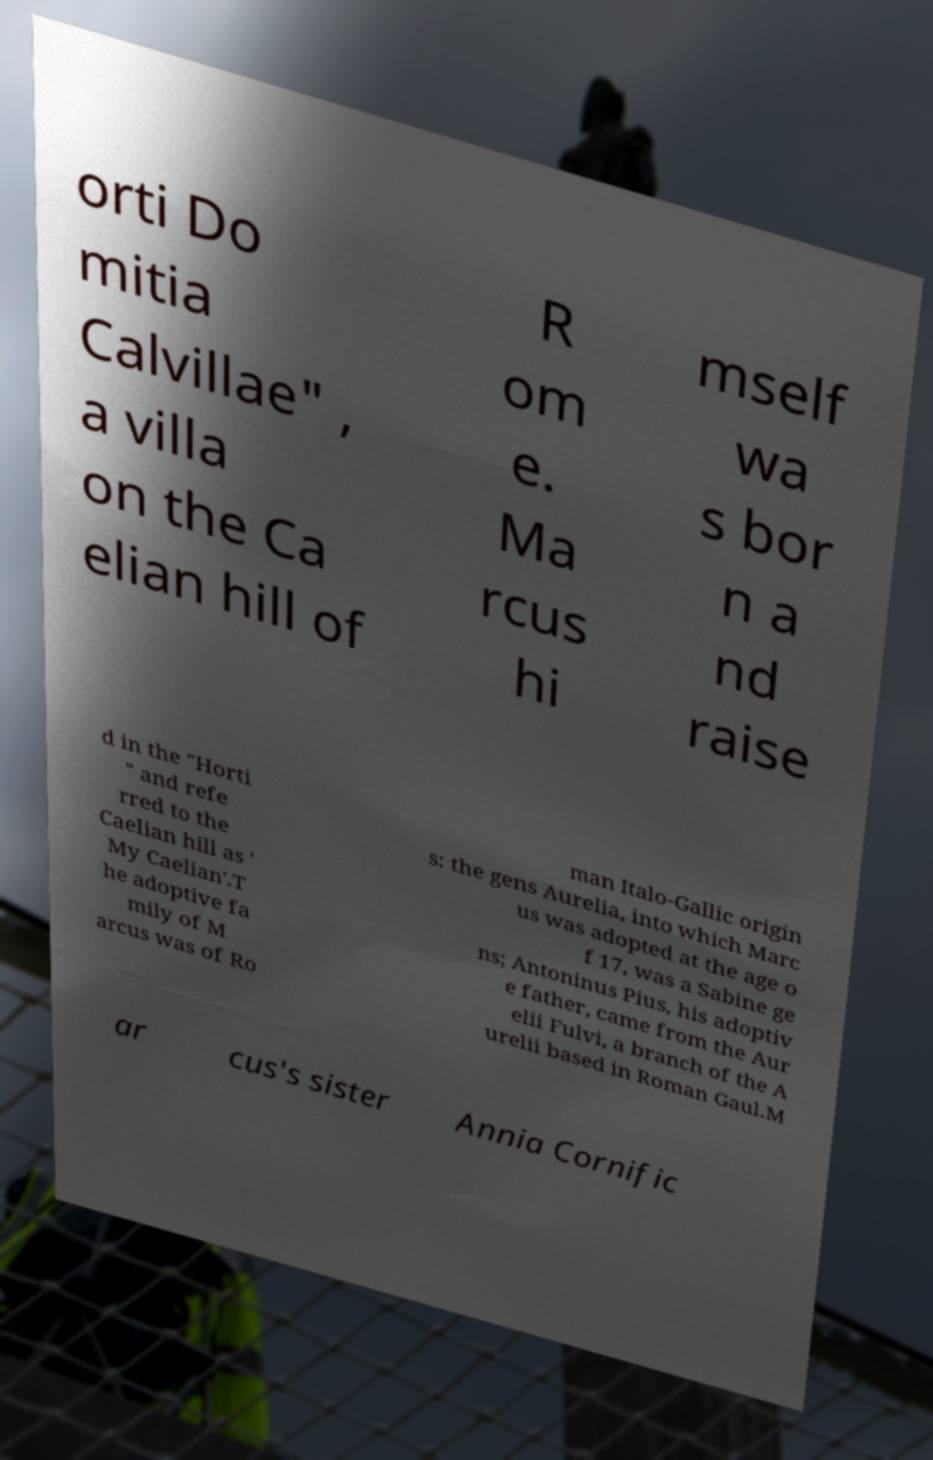Please identify and transcribe the text found in this image. orti Do mitia Calvillae" , a villa on the Ca elian hill of R om e. Ma rcus hi mself wa s bor n a nd raise d in the "Horti " and refe rred to the Caelian hill as ' My Caelian'.T he adoptive fa mily of M arcus was of Ro man Italo-Gallic origin s: the gens Aurelia, into which Marc us was adopted at the age o f 17, was a Sabine ge ns; Antoninus Pius, his adoptiv e father, came from the Aur elii Fulvi, a branch of the A urelii based in Roman Gaul.M ar cus's sister Annia Cornific 